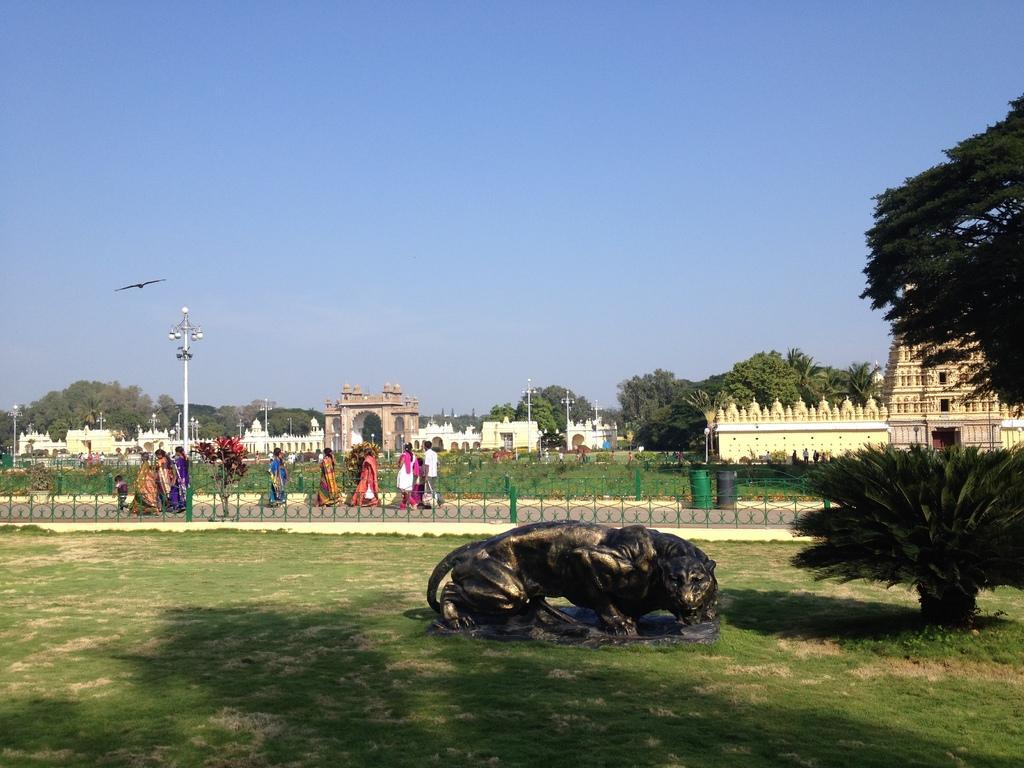Describe this image in one or two sentences. In this image we can see one temple, so many buildings, some people are walking on the road, one garden, some people standing, some poles with lights. There are so many trees, plants, bushes, some objects are on the surface, one statue and some green grass on the ground. One bird flying in the sky and some people are holding some objects. 